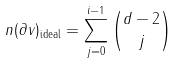<formula> <loc_0><loc_0><loc_500><loc_500>n ( \partial v ) _ { \text {ideal} } = \sum _ { j = 0 } ^ { i - 1 } { d - 2 \choose j }</formula> 